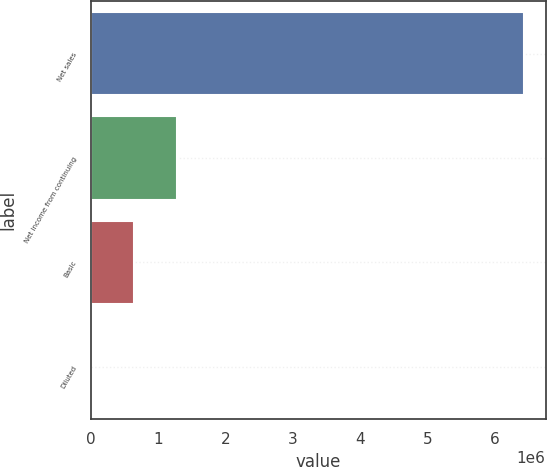Convert chart to OTSL. <chart><loc_0><loc_0><loc_500><loc_500><bar_chart><fcel>Net sales<fcel>Net income from continuing<fcel>Basic<fcel>Diluted<nl><fcel>6.43493e+06<fcel>1.28699e+06<fcel>643494<fcel>1.61<nl></chart> 